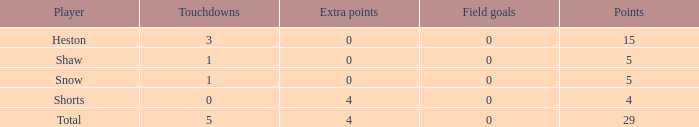What is the total number of field goals a player had when there were more than 0 extra points and there were 5 touchdowns? 1.0. 